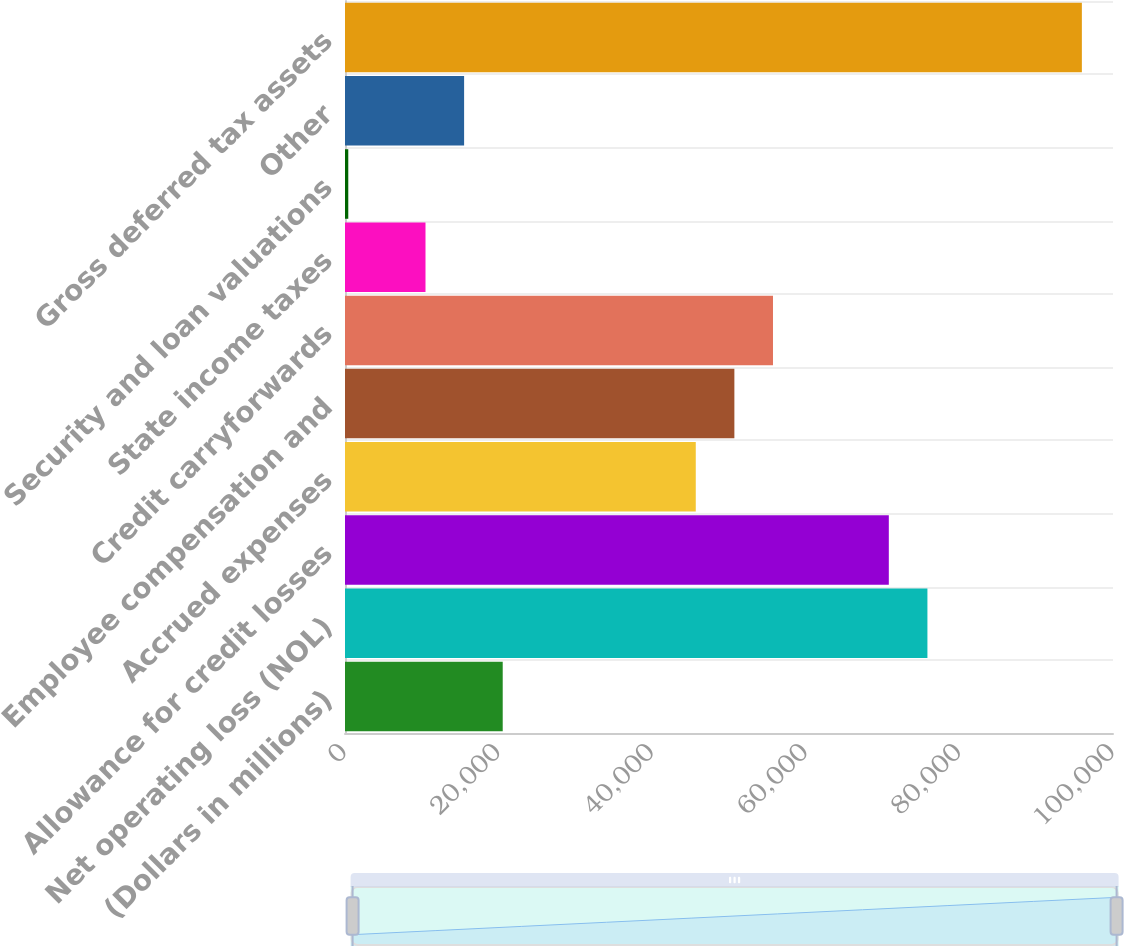<chart> <loc_0><loc_0><loc_500><loc_500><bar_chart><fcel>(Dollars in millions)<fcel>Net operating loss (NOL)<fcel>Allowance for credit losses<fcel>Accrued expenses<fcel>Employee compensation and<fcel>Credit carryforwards<fcel>State income taxes<fcel>Security and loan valuations<fcel>Other<fcel>Gross deferred tax assets<nl><fcel>20536.2<fcel>75836.5<fcel>70809.2<fcel>45672.7<fcel>50700<fcel>55727.3<fcel>10481.6<fcel>427<fcel>15508.9<fcel>95945.7<nl></chart> 